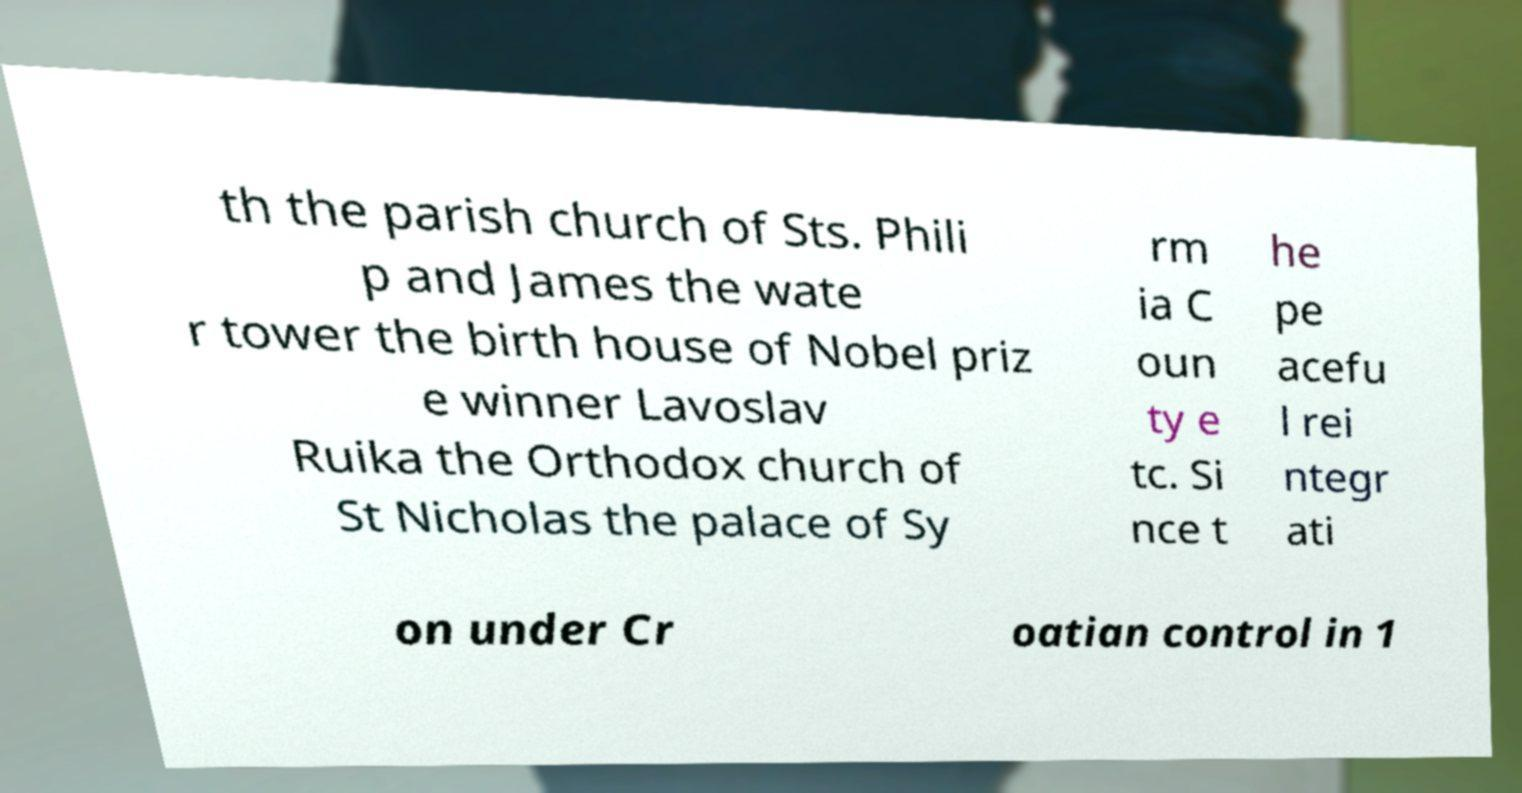Please read and relay the text visible in this image. What does it say? th the parish church of Sts. Phili p and James the wate r tower the birth house of Nobel priz e winner Lavoslav Ruika the Orthodox church of St Nicholas the palace of Sy rm ia C oun ty e tc. Si nce t he pe acefu l rei ntegr ati on under Cr oatian control in 1 